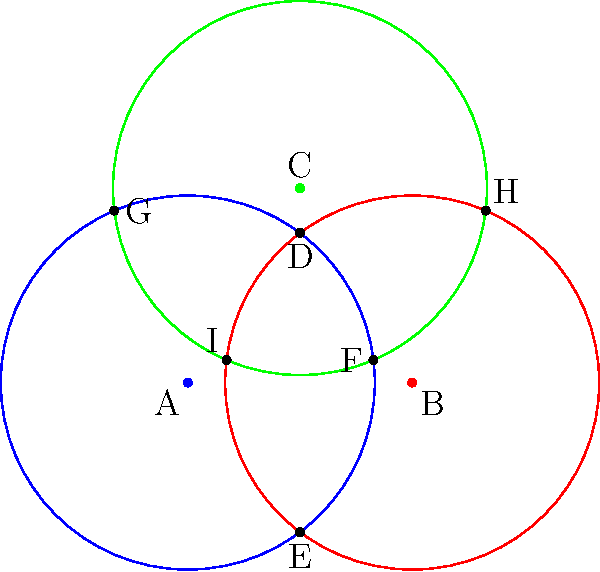In the diagram, three circles represent different resource distribution areas in a city. Circle A represents funding for infrastructure, Circle B for education, and Circle C for healthcare. Each circle has a radius of 2.5 units. If the centers of circles A and B are 3 units apart, and the center of circle C is positioned such that it intersects with both A and B, how many distinct intersection points are there in total? How does this relate to the concept of overlapping resource allocation? To solve this problem, we need to analyze the intersections between the circles:

1. Circles A and B intersect at two points (D and E).
2. Circles A and C intersect at two points (F and G).
3. Circles B and C intersect at two points (H and I).

To determine if these intersection points are distinct, we need to check if any of them coincide:

4. Given the symmetry of the arrangement and the equal radii of the circles, we can conclude that all six intersection points are distinct.

5. Counting the distinct intersection points:
   2 (A∩B) + 2 (A∩C) + 2 (B∩C) = 6 distinct points

6. Relating to resource allocation:
   - Each intersection point represents an area where two types of resources overlap.
   - The six distinct points indicate six unique areas of overlap between pairs of resources.
   - The central region, where all three circles overlap, represents an area benefiting from all three resource types.
   - This diagram illustrates how spreading resources across different areas can create multiple zones of interaction and potential synergy between different sectors (infrastructure, education, and healthcare in this case).
Answer: 6 distinct intersection points 